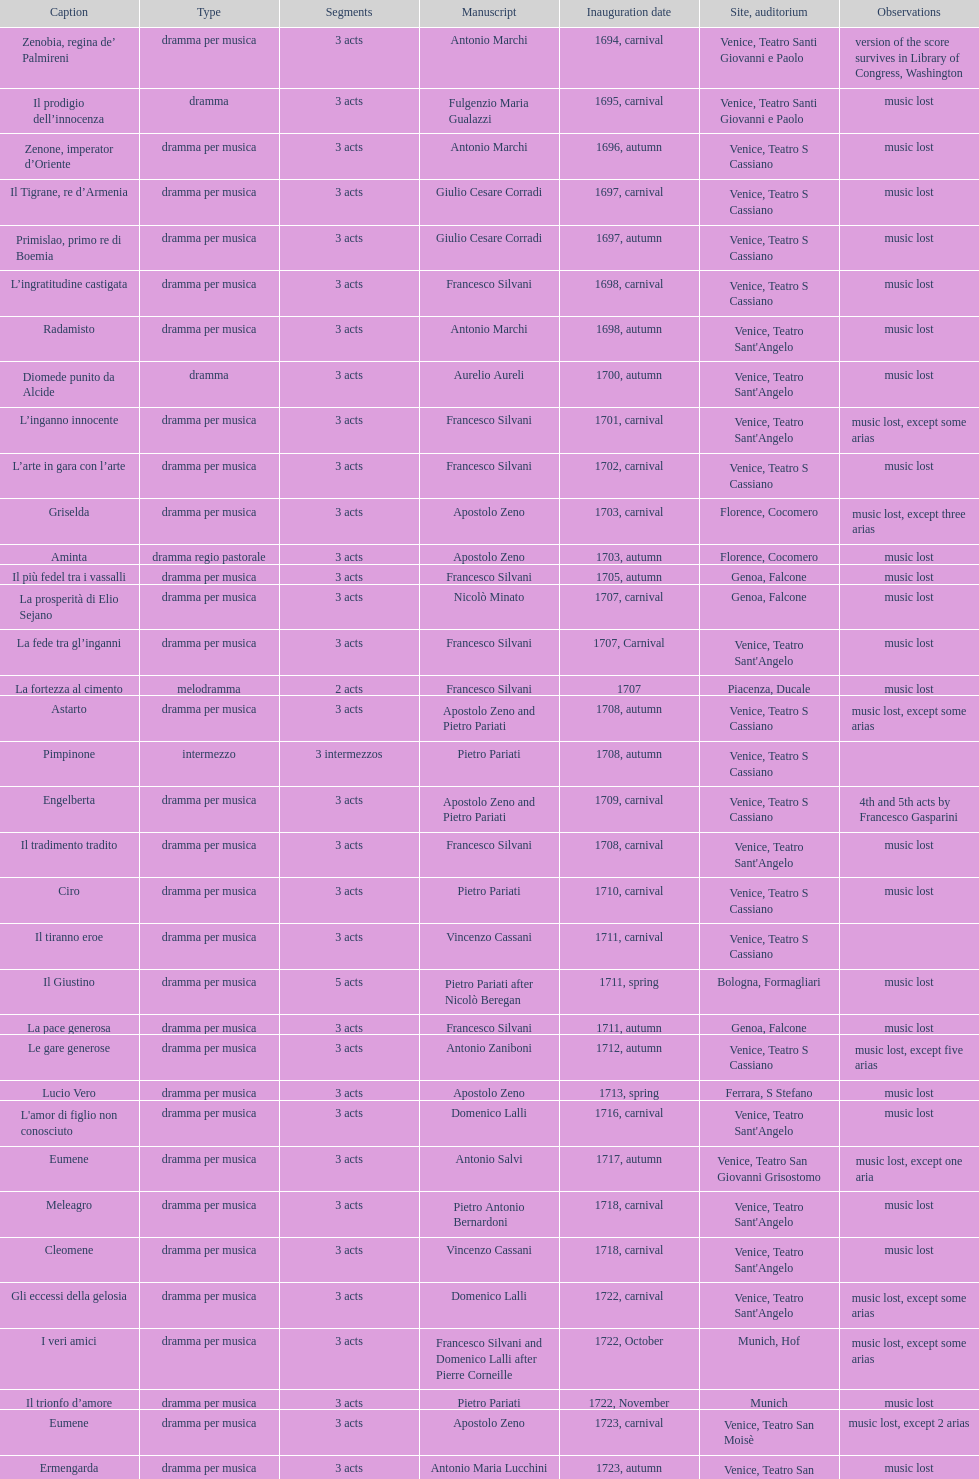L'inganno innocente premiered in 1701. what was the previous title released? Diomede punito da Alcide. 